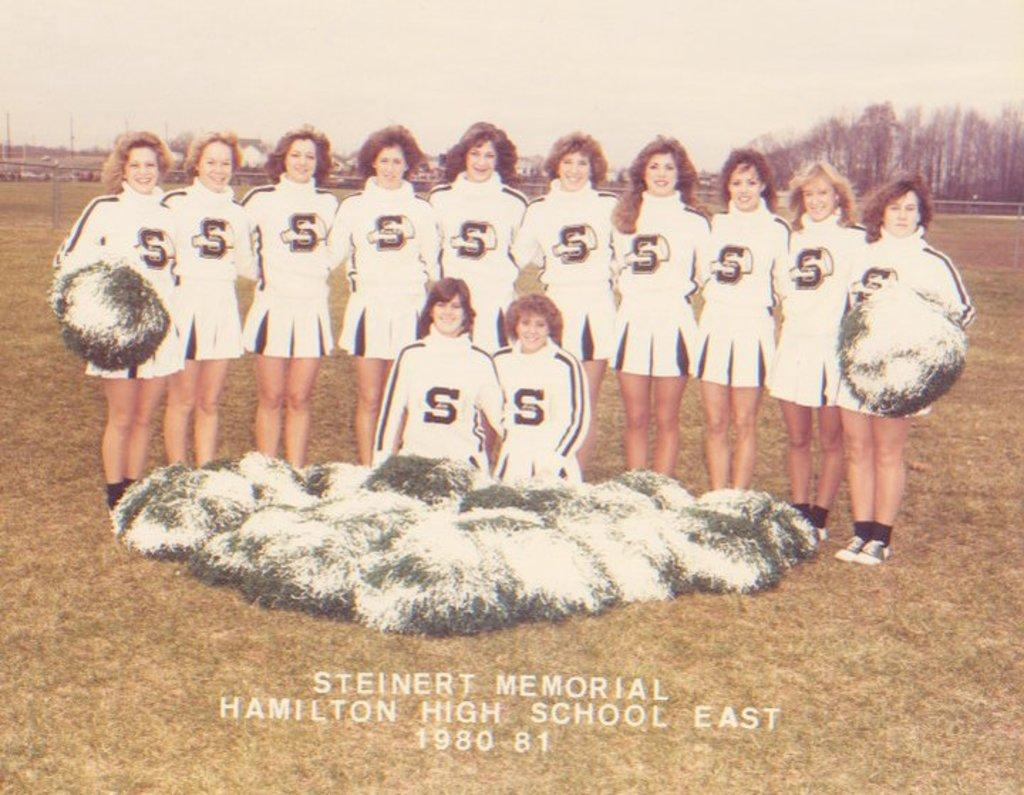<image>
Give a short and clear explanation of the subsequent image. Steinert Memorial 1980-81 cheerleaders posed for a picture 